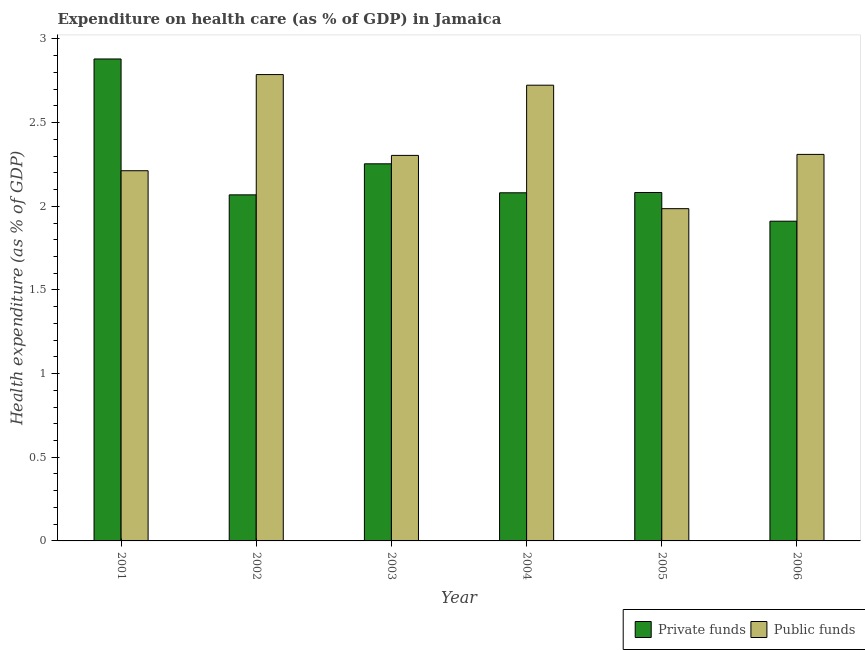Are the number of bars per tick equal to the number of legend labels?
Ensure brevity in your answer.  Yes. Are the number of bars on each tick of the X-axis equal?
Ensure brevity in your answer.  Yes. How many bars are there on the 4th tick from the left?
Offer a terse response. 2. What is the label of the 3rd group of bars from the left?
Provide a succinct answer. 2003. In how many cases, is the number of bars for a given year not equal to the number of legend labels?
Provide a short and direct response. 0. What is the amount of private funds spent in healthcare in 2006?
Your answer should be very brief. 1.91. Across all years, what is the maximum amount of private funds spent in healthcare?
Make the answer very short. 2.88. Across all years, what is the minimum amount of public funds spent in healthcare?
Your answer should be very brief. 1.99. In which year was the amount of public funds spent in healthcare minimum?
Provide a short and direct response. 2005. What is the total amount of private funds spent in healthcare in the graph?
Provide a short and direct response. 13.28. What is the difference between the amount of public funds spent in healthcare in 2001 and that in 2003?
Offer a terse response. -0.09. What is the difference between the amount of public funds spent in healthcare in 2003 and the amount of private funds spent in healthcare in 2002?
Your answer should be very brief. -0.48. What is the average amount of public funds spent in healthcare per year?
Offer a very short reply. 2.39. In how many years, is the amount of public funds spent in healthcare greater than 2.3 %?
Your answer should be compact. 4. What is the ratio of the amount of private funds spent in healthcare in 2001 to that in 2003?
Your response must be concise. 1.28. Is the amount of private funds spent in healthcare in 2001 less than that in 2005?
Provide a short and direct response. No. What is the difference between the highest and the second highest amount of public funds spent in healthcare?
Ensure brevity in your answer.  0.06. What is the difference between the highest and the lowest amount of private funds spent in healthcare?
Provide a short and direct response. 0.97. What does the 1st bar from the left in 2004 represents?
Provide a succinct answer. Private funds. What does the 1st bar from the right in 2002 represents?
Provide a succinct answer. Public funds. Are the values on the major ticks of Y-axis written in scientific E-notation?
Your response must be concise. No. Does the graph contain any zero values?
Your response must be concise. No. Does the graph contain grids?
Offer a very short reply. No. How are the legend labels stacked?
Provide a succinct answer. Horizontal. What is the title of the graph?
Your response must be concise. Expenditure on health care (as % of GDP) in Jamaica. What is the label or title of the Y-axis?
Provide a succinct answer. Health expenditure (as % of GDP). What is the Health expenditure (as % of GDP) in Private funds in 2001?
Make the answer very short. 2.88. What is the Health expenditure (as % of GDP) in Public funds in 2001?
Keep it short and to the point. 2.21. What is the Health expenditure (as % of GDP) in Private funds in 2002?
Provide a succinct answer. 2.07. What is the Health expenditure (as % of GDP) in Public funds in 2002?
Provide a succinct answer. 2.79. What is the Health expenditure (as % of GDP) of Private funds in 2003?
Your answer should be very brief. 2.25. What is the Health expenditure (as % of GDP) of Public funds in 2003?
Your answer should be very brief. 2.3. What is the Health expenditure (as % of GDP) in Private funds in 2004?
Your answer should be very brief. 2.08. What is the Health expenditure (as % of GDP) in Public funds in 2004?
Make the answer very short. 2.72. What is the Health expenditure (as % of GDP) in Private funds in 2005?
Provide a succinct answer. 2.08. What is the Health expenditure (as % of GDP) in Public funds in 2005?
Your response must be concise. 1.99. What is the Health expenditure (as % of GDP) in Private funds in 2006?
Provide a succinct answer. 1.91. What is the Health expenditure (as % of GDP) in Public funds in 2006?
Your answer should be compact. 2.31. Across all years, what is the maximum Health expenditure (as % of GDP) of Private funds?
Give a very brief answer. 2.88. Across all years, what is the maximum Health expenditure (as % of GDP) in Public funds?
Make the answer very short. 2.79. Across all years, what is the minimum Health expenditure (as % of GDP) in Private funds?
Your response must be concise. 1.91. Across all years, what is the minimum Health expenditure (as % of GDP) of Public funds?
Keep it short and to the point. 1.99. What is the total Health expenditure (as % of GDP) in Private funds in the graph?
Give a very brief answer. 13.28. What is the total Health expenditure (as % of GDP) in Public funds in the graph?
Your answer should be very brief. 14.32. What is the difference between the Health expenditure (as % of GDP) in Private funds in 2001 and that in 2002?
Your response must be concise. 0.81. What is the difference between the Health expenditure (as % of GDP) of Public funds in 2001 and that in 2002?
Offer a terse response. -0.57. What is the difference between the Health expenditure (as % of GDP) of Private funds in 2001 and that in 2003?
Ensure brevity in your answer.  0.63. What is the difference between the Health expenditure (as % of GDP) in Public funds in 2001 and that in 2003?
Offer a very short reply. -0.09. What is the difference between the Health expenditure (as % of GDP) of Private funds in 2001 and that in 2004?
Your response must be concise. 0.8. What is the difference between the Health expenditure (as % of GDP) in Public funds in 2001 and that in 2004?
Ensure brevity in your answer.  -0.51. What is the difference between the Health expenditure (as % of GDP) in Private funds in 2001 and that in 2005?
Offer a very short reply. 0.8. What is the difference between the Health expenditure (as % of GDP) in Public funds in 2001 and that in 2005?
Provide a succinct answer. 0.23. What is the difference between the Health expenditure (as % of GDP) in Private funds in 2001 and that in 2006?
Provide a succinct answer. 0.97. What is the difference between the Health expenditure (as % of GDP) in Public funds in 2001 and that in 2006?
Make the answer very short. -0.1. What is the difference between the Health expenditure (as % of GDP) in Private funds in 2002 and that in 2003?
Offer a very short reply. -0.19. What is the difference between the Health expenditure (as % of GDP) of Public funds in 2002 and that in 2003?
Give a very brief answer. 0.48. What is the difference between the Health expenditure (as % of GDP) of Private funds in 2002 and that in 2004?
Give a very brief answer. -0.01. What is the difference between the Health expenditure (as % of GDP) in Public funds in 2002 and that in 2004?
Ensure brevity in your answer.  0.06. What is the difference between the Health expenditure (as % of GDP) of Private funds in 2002 and that in 2005?
Keep it short and to the point. -0.01. What is the difference between the Health expenditure (as % of GDP) in Public funds in 2002 and that in 2005?
Ensure brevity in your answer.  0.8. What is the difference between the Health expenditure (as % of GDP) of Private funds in 2002 and that in 2006?
Offer a terse response. 0.16. What is the difference between the Health expenditure (as % of GDP) of Public funds in 2002 and that in 2006?
Your response must be concise. 0.48. What is the difference between the Health expenditure (as % of GDP) in Private funds in 2003 and that in 2004?
Make the answer very short. 0.17. What is the difference between the Health expenditure (as % of GDP) in Public funds in 2003 and that in 2004?
Your answer should be very brief. -0.42. What is the difference between the Health expenditure (as % of GDP) in Private funds in 2003 and that in 2005?
Provide a succinct answer. 0.17. What is the difference between the Health expenditure (as % of GDP) of Public funds in 2003 and that in 2005?
Your answer should be very brief. 0.32. What is the difference between the Health expenditure (as % of GDP) of Private funds in 2003 and that in 2006?
Provide a short and direct response. 0.34. What is the difference between the Health expenditure (as % of GDP) of Public funds in 2003 and that in 2006?
Keep it short and to the point. -0.01. What is the difference between the Health expenditure (as % of GDP) of Private funds in 2004 and that in 2005?
Offer a terse response. -0. What is the difference between the Health expenditure (as % of GDP) of Public funds in 2004 and that in 2005?
Offer a terse response. 0.74. What is the difference between the Health expenditure (as % of GDP) in Private funds in 2004 and that in 2006?
Ensure brevity in your answer.  0.17. What is the difference between the Health expenditure (as % of GDP) in Public funds in 2004 and that in 2006?
Your answer should be very brief. 0.41. What is the difference between the Health expenditure (as % of GDP) in Private funds in 2005 and that in 2006?
Keep it short and to the point. 0.17. What is the difference between the Health expenditure (as % of GDP) in Public funds in 2005 and that in 2006?
Your answer should be compact. -0.32. What is the difference between the Health expenditure (as % of GDP) of Private funds in 2001 and the Health expenditure (as % of GDP) of Public funds in 2002?
Keep it short and to the point. 0.09. What is the difference between the Health expenditure (as % of GDP) of Private funds in 2001 and the Health expenditure (as % of GDP) of Public funds in 2003?
Your response must be concise. 0.58. What is the difference between the Health expenditure (as % of GDP) in Private funds in 2001 and the Health expenditure (as % of GDP) in Public funds in 2004?
Give a very brief answer. 0.16. What is the difference between the Health expenditure (as % of GDP) in Private funds in 2001 and the Health expenditure (as % of GDP) in Public funds in 2005?
Make the answer very short. 0.89. What is the difference between the Health expenditure (as % of GDP) in Private funds in 2001 and the Health expenditure (as % of GDP) in Public funds in 2006?
Offer a terse response. 0.57. What is the difference between the Health expenditure (as % of GDP) of Private funds in 2002 and the Health expenditure (as % of GDP) of Public funds in 2003?
Offer a very short reply. -0.24. What is the difference between the Health expenditure (as % of GDP) in Private funds in 2002 and the Health expenditure (as % of GDP) in Public funds in 2004?
Your answer should be compact. -0.66. What is the difference between the Health expenditure (as % of GDP) of Private funds in 2002 and the Health expenditure (as % of GDP) of Public funds in 2005?
Offer a very short reply. 0.08. What is the difference between the Health expenditure (as % of GDP) in Private funds in 2002 and the Health expenditure (as % of GDP) in Public funds in 2006?
Your answer should be compact. -0.24. What is the difference between the Health expenditure (as % of GDP) of Private funds in 2003 and the Health expenditure (as % of GDP) of Public funds in 2004?
Your answer should be compact. -0.47. What is the difference between the Health expenditure (as % of GDP) of Private funds in 2003 and the Health expenditure (as % of GDP) of Public funds in 2005?
Provide a short and direct response. 0.27. What is the difference between the Health expenditure (as % of GDP) in Private funds in 2003 and the Health expenditure (as % of GDP) in Public funds in 2006?
Provide a succinct answer. -0.06. What is the difference between the Health expenditure (as % of GDP) of Private funds in 2004 and the Health expenditure (as % of GDP) of Public funds in 2005?
Ensure brevity in your answer.  0.09. What is the difference between the Health expenditure (as % of GDP) of Private funds in 2004 and the Health expenditure (as % of GDP) of Public funds in 2006?
Give a very brief answer. -0.23. What is the difference between the Health expenditure (as % of GDP) of Private funds in 2005 and the Health expenditure (as % of GDP) of Public funds in 2006?
Provide a short and direct response. -0.23. What is the average Health expenditure (as % of GDP) of Private funds per year?
Make the answer very short. 2.21. What is the average Health expenditure (as % of GDP) in Public funds per year?
Offer a terse response. 2.39. In the year 2001, what is the difference between the Health expenditure (as % of GDP) of Private funds and Health expenditure (as % of GDP) of Public funds?
Your response must be concise. 0.67. In the year 2002, what is the difference between the Health expenditure (as % of GDP) in Private funds and Health expenditure (as % of GDP) in Public funds?
Offer a very short reply. -0.72. In the year 2003, what is the difference between the Health expenditure (as % of GDP) of Private funds and Health expenditure (as % of GDP) of Public funds?
Your response must be concise. -0.05. In the year 2004, what is the difference between the Health expenditure (as % of GDP) in Private funds and Health expenditure (as % of GDP) in Public funds?
Keep it short and to the point. -0.64. In the year 2005, what is the difference between the Health expenditure (as % of GDP) in Private funds and Health expenditure (as % of GDP) in Public funds?
Offer a very short reply. 0.1. In the year 2006, what is the difference between the Health expenditure (as % of GDP) of Private funds and Health expenditure (as % of GDP) of Public funds?
Your answer should be compact. -0.4. What is the ratio of the Health expenditure (as % of GDP) in Private funds in 2001 to that in 2002?
Offer a very short reply. 1.39. What is the ratio of the Health expenditure (as % of GDP) of Public funds in 2001 to that in 2002?
Keep it short and to the point. 0.79. What is the ratio of the Health expenditure (as % of GDP) in Private funds in 2001 to that in 2003?
Provide a short and direct response. 1.28. What is the ratio of the Health expenditure (as % of GDP) of Public funds in 2001 to that in 2003?
Provide a short and direct response. 0.96. What is the ratio of the Health expenditure (as % of GDP) of Private funds in 2001 to that in 2004?
Offer a terse response. 1.38. What is the ratio of the Health expenditure (as % of GDP) in Public funds in 2001 to that in 2004?
Your response must be concise. 0.81. What is the ratio of the Health expenditure (as % of GDP) in Private funds in 2001 to that in 2005?
Your response must be concise. 1.38. What is the ratio of the Health expenditure (as % of GDP) of Public funds in 2001 to that in 2005?
Your answer should be compact. 1.11. What is the ratio of the Health expenditure (as % of GDP) of Private funds in 2001 to that in 2006?
Offer a terse response. 1.51. What is the ratio of the Health expenditure (as % of GDP) in Public funds in 2001 to that in 2006?
Ensure brevity in your answer.  0.96. What is the ratio of the Health expenditure (as % of GDP) of Private funds in 2002 to that in 2003?
Ensure brevity in your answer.  0.92. What is the ratio of the Health expenditure (as % of GDP) of Public funds in 2002 to that in 2003?
Keep it short and to the point. 1.21. What is the ratio of the Health expenditure (as % of GDP) of Private funds in 2002 to that in 2004?
Provide a succinct answer. 0.99. What is the ratio of the Health expenditure (as % of GDP) of Public funds in 2002 to that in 2004?
Make the answer very short. 1.02. What is the ratio of the Health expenditure (as % of GDP) in Public funds in 2002 to that in 2005?
Your answer should be very brief. 1.4. What is the ratio of the Health expenditure (as % of GDP) in Private funds in 2002 to that in 2006?
Provide a short and direct response. 1.08. What is the ratio of the Health expenditure (as % of GDP) in Public funds in 2002 to that in 2006?
Provide a succinct answer. 1.21. What is the ratio of the Health expenditure (as % of GDP) in Private funds in 2003 to that in 2004?
Provide a succinct answer. 1.08. What is the ratio of the Health expenditure (as % of GDP) of Public funds in 2003 to that in 2004?
Provide a succinct answer. 0.85. What is the ratio of the Health expenditure (as % of GDP) of Private funds in 2003 to that in 2005?
Provide a short and direct response. 1.08. What is the ratio of the Health expenditure (as % of GDP) in Public funds in 2003 to that in 2005?
Offer a very short reply. 1.16. What is the ratio of the Health expenditure (as % of GDP) of Private funds in 2003 to that in 2006?
Your answer should be very brief. 1.18. What is the ratio of the Health expenditure (as % of GDP) of Public funds in 2004 to that in 2005?
Give a very brief answer. 1.37. What is the ratio of the Health expenditure (as % of GDP) of Private funds in 2004 to that in 2006?
Make the answer very short. 1.09. What is the ratio of the Health expenditure (as % of GDP) of Public funds in 2004 to that in 2006?
Your answer should be compact. 1.18. What is the ratio of the Health expenditure (as % of GDP) of Private funds in 2005 to that in 2006?
Provide a succinct answer. 1.09. What is the ratio of the Health expenditure (as % of GDP) of Public funds in 2005 to that in 2006?
Make the answer very short. 0.86. What is the difference between the highest and the second highest Health expenditure (as % of GDP) in Private funds?
Ensure brevity in your answer.  0.63. What is the difference between the highest and the second highest Health expenditure (as % of GDP) in Public funds?
Your response must be concise. 0.06. What is the difference between the highest and the lowest Health expenditure (as % of GDP) in Private funds?
Give a very brief answer. 0.97. What is the difference between the highest and the lowest Health expenditure (as % of GDP) in Public funds?
Offer a very short reply. 0.8. 